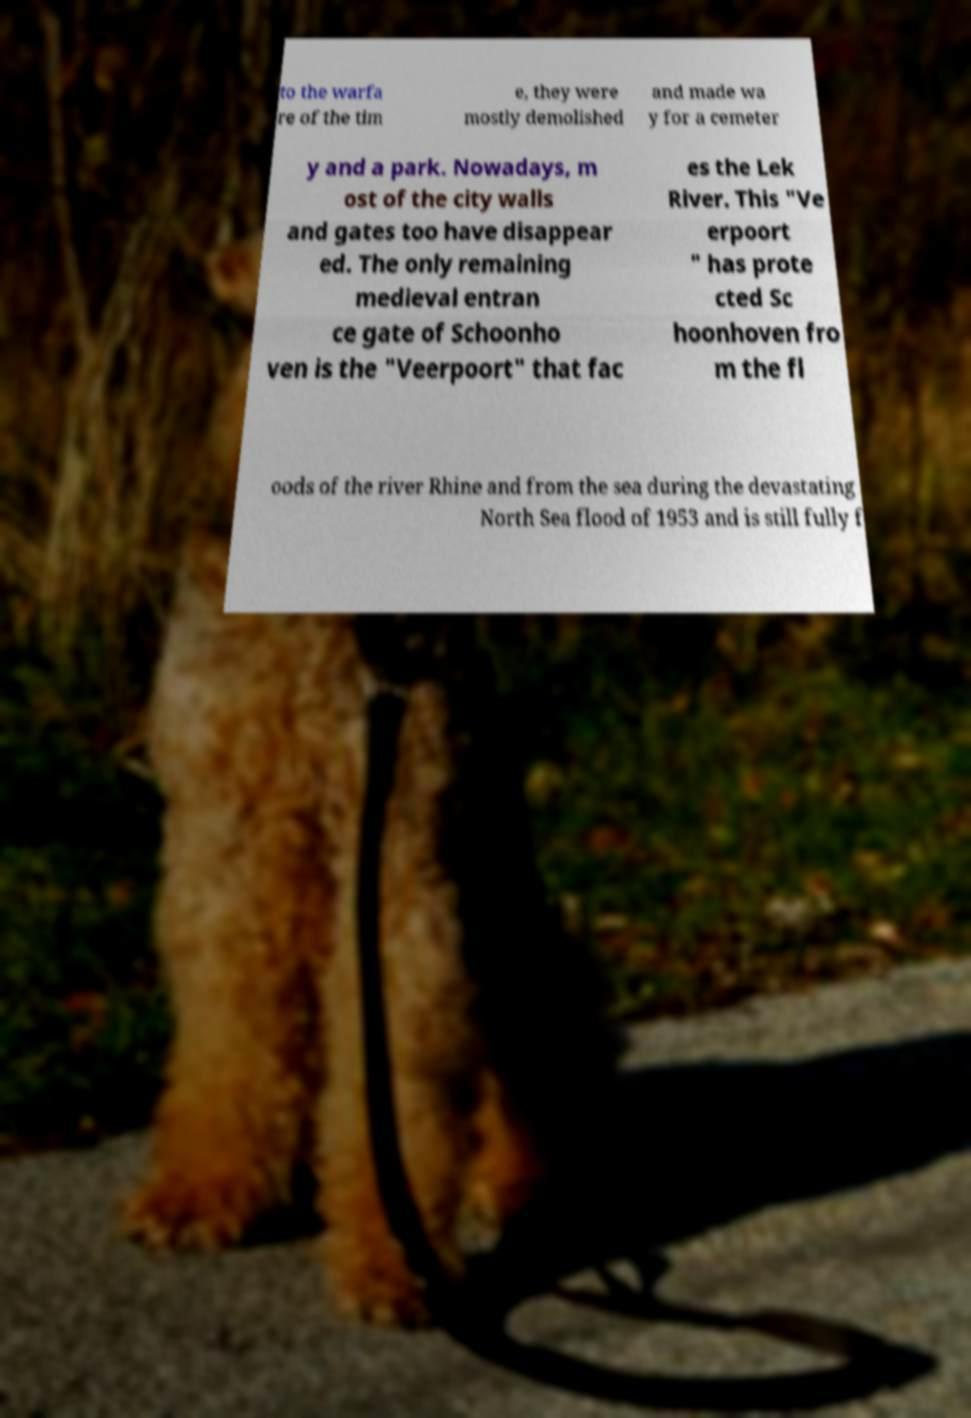Can you read and provide the text displayed in the image?This photo seems to have some interesting text. Can you extract and type it out for me? to the warfa re of the tim e, they were mostly demolished and made wa y for a cemeter y and a park. Nowadays, m ost of the city walls and gates too have disappear ed. The only remaining medieval entran ce gate of Schoonho ven is the "Veerpoort" that fac es the Lek River. This "Ve erpoort " has prote cted Sc hoonhoven fro m the fl oods of the river Rhine and from the sea during the devastating North Sea flood of 1953 and is still fully f 